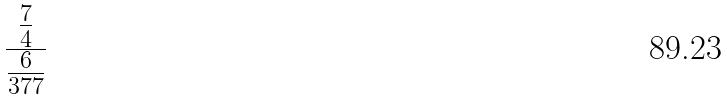<formula> <loc_0><loc_0><loc_500><loc_500>\frac { \frac { 7 } { 4 } } { \frac { 6 } { 3 7 7 } }</formula> 